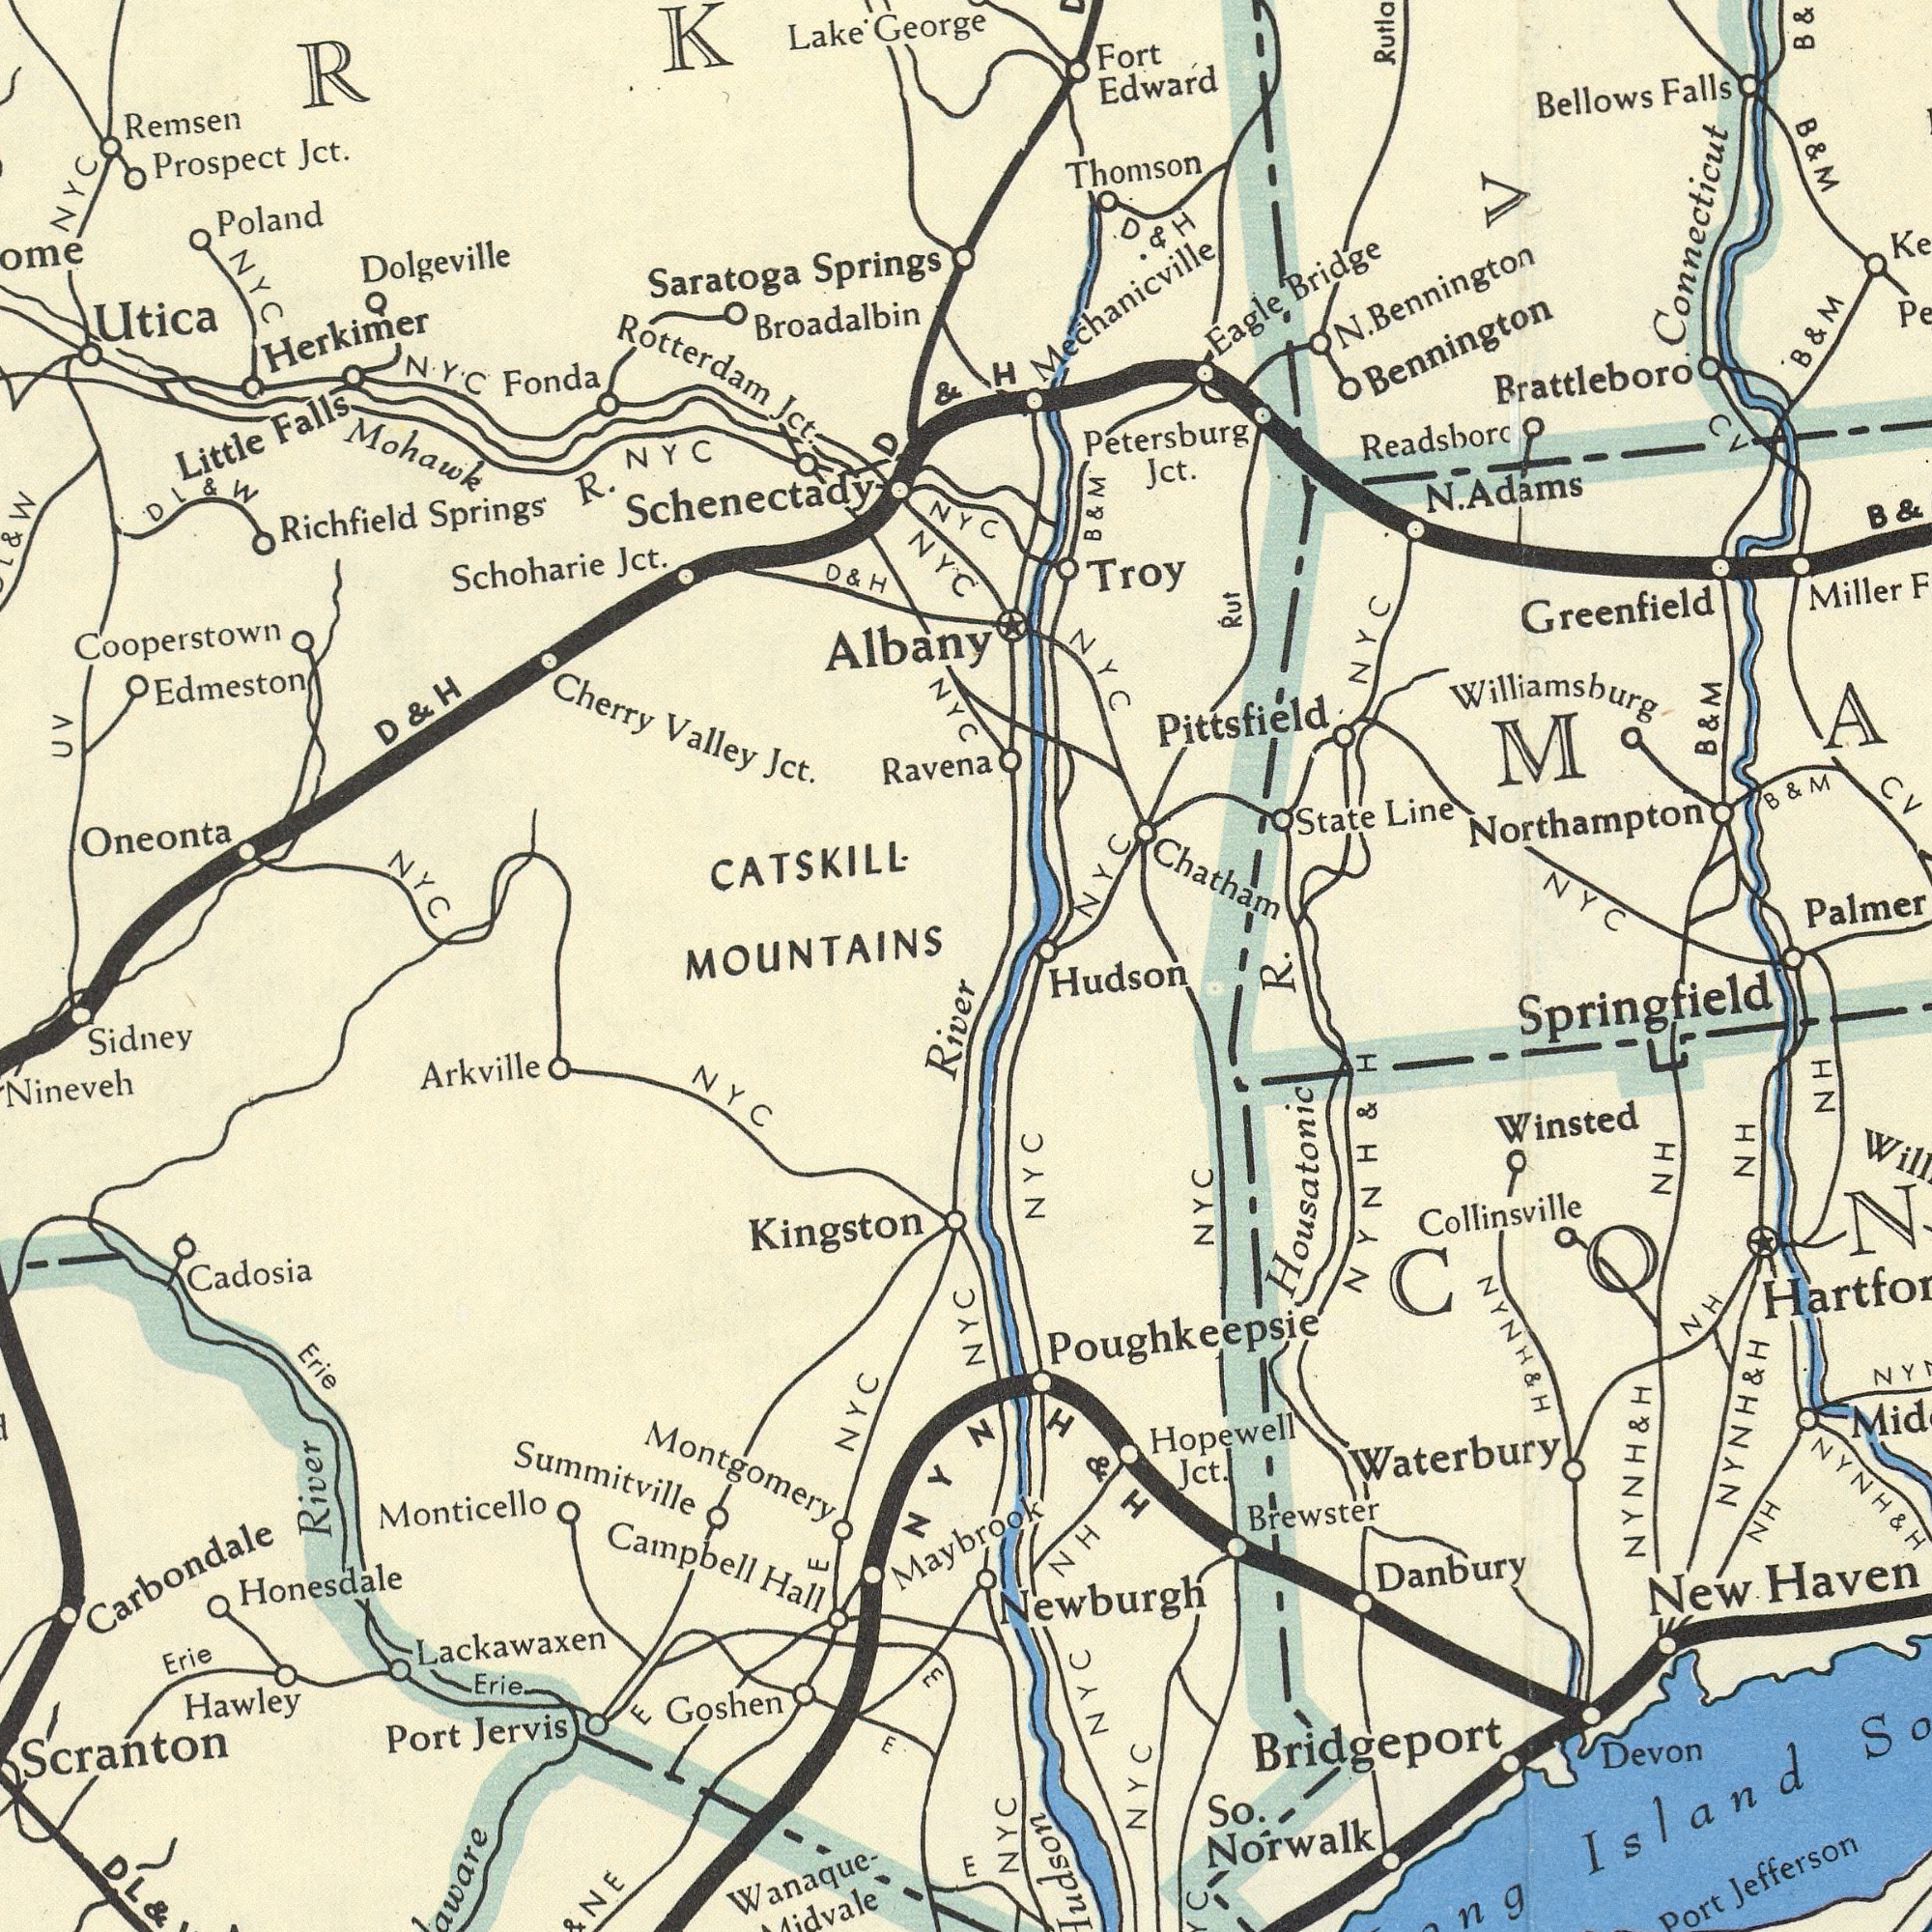What text is visible in the lower-left corner? Lackawaxen Montgomery Nineveh Honesdale Campbell Summitville Carbondale Arkville Sidney Monticello Jervis Erie Kingston Goshen Hall Cadosia Port Hawley Wanaque- River DL Erie Erie E Scranton E NYC NYC River E E & & NE What text appears in the top-left area of the image? Rotterdam Broadalbin Cooperstown Dolgeville Schoharie Mohawk Richfield Oneonta Utica Jct. Valley Springs Jct. Cherry Prospect Jct. UV Albany NYC Little D Jct. Falls Lake CATSKILL. D Herkimer Saratoga Poland Springs George Ravena MOUNTAINS Fonda Remsen NYC NYC NYC NYC Schenectady Edmeston & D NYC R. NYC DL & W & W & H & H What text is shown in the top-right quadrant? NYC Chatham Petersburg Greenfield Mechanicville Brattleboro Readsborc Bennington Edward Miller B Thomson State Bellows Line NYC Bridge NYC Troy Fort Williamsburg NYC Rut Eagle Jct. Falls B B B Bennington B N. NYC B Pittsfield B Adams CV H N. CV & Northampton V Connecticut D H & M & & M & & M & M & M What text is visible in the lower-right corner? Maybrook Hudson Brewster Jefferson Hopewell NYC Haven NYC Port So. Collinsville Norwalk NH NH NH NYC Winsted Jct. NYC NYC NH Springfield Danbury Poughkeepsie NH Devon New Bridgeport Newburgh Island Housatonic Waterbury NYC & R. & H & H & H & H & H E H HN NYNH NYNH NYNH NYNH NYNH NYNH 